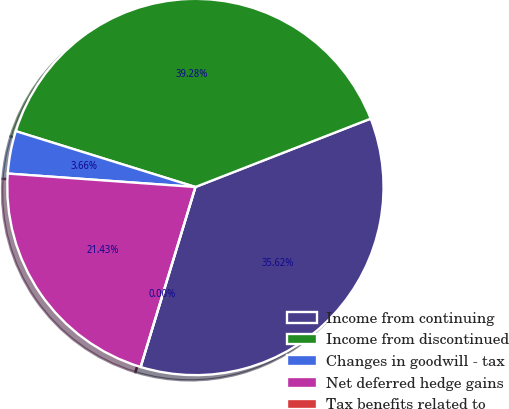Convert chart to OTSL. <chart><loc_0><loc_0><loc_500><loc_500><pie_chart><fcel>Income from continuing<fcel>Income from discontinued<fcel>Changes in goodwill - tax<fcel>Net deferred hedge gains<fcel>Tax benefits related to<nl><fcel>35.62%<fcel>39.28%<fcel>3.66%<fcel>21.43%<fcel>0.0%<nl></chart> 